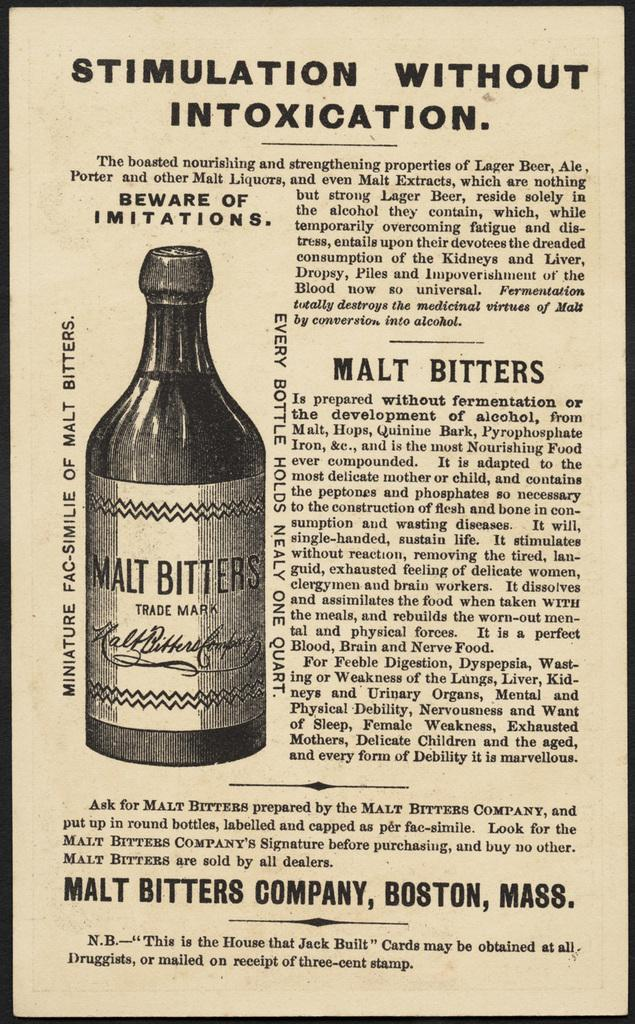Provide a one-sentence caption for the provided image. An old black and white advert in a newspaper offering Malt Bitters which promises to make you feel good but not drunk. 